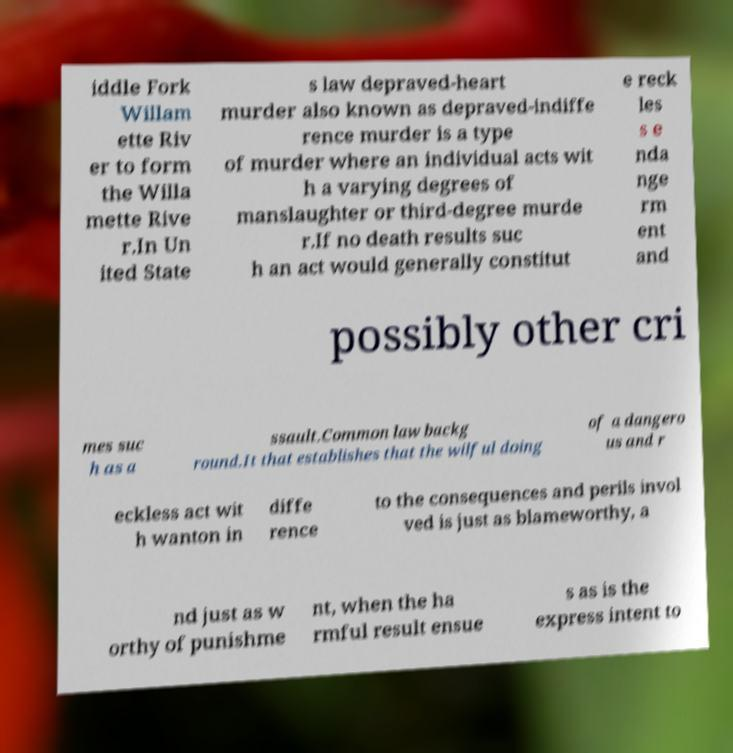Could you extract and type out the text from this image? iddle Fork Willam ette Riv er to form the Willa mette Rive r.In Un ited State s law depraved-heart murder also known as depraved-indiffe rence murder is a type of murder where an individual acts wit h a varying degrees of manslaughter or third-degree murde r.If no death results suc h an act would generally constitut e reck les s e nda nge rm ent and possibly other cri mes suc h as a ssault.Common law backg round.It that establishes that the wilful doing of a dangero us and r eckless act wit h wanton in diffe rence to the consequences and perils invol ved is just as blameworthy, a nd just as w orthy of punishme nt, when the ha rmful result ensue s as is the express intent to 